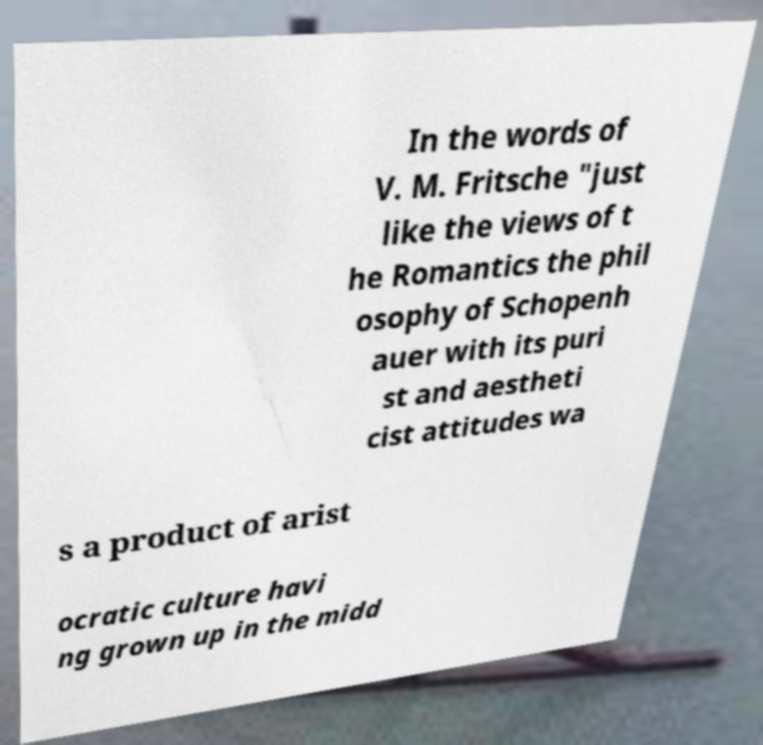Please read and relay the text visible in this image. What does it say? In the words of V. M. Fritsche "just like the views of t he Romantics the phil osophy of Schopenh auer with its puri st and aestheti cist attitudes wa s a product of arist ocratic culture havi ng grown up in the midd 